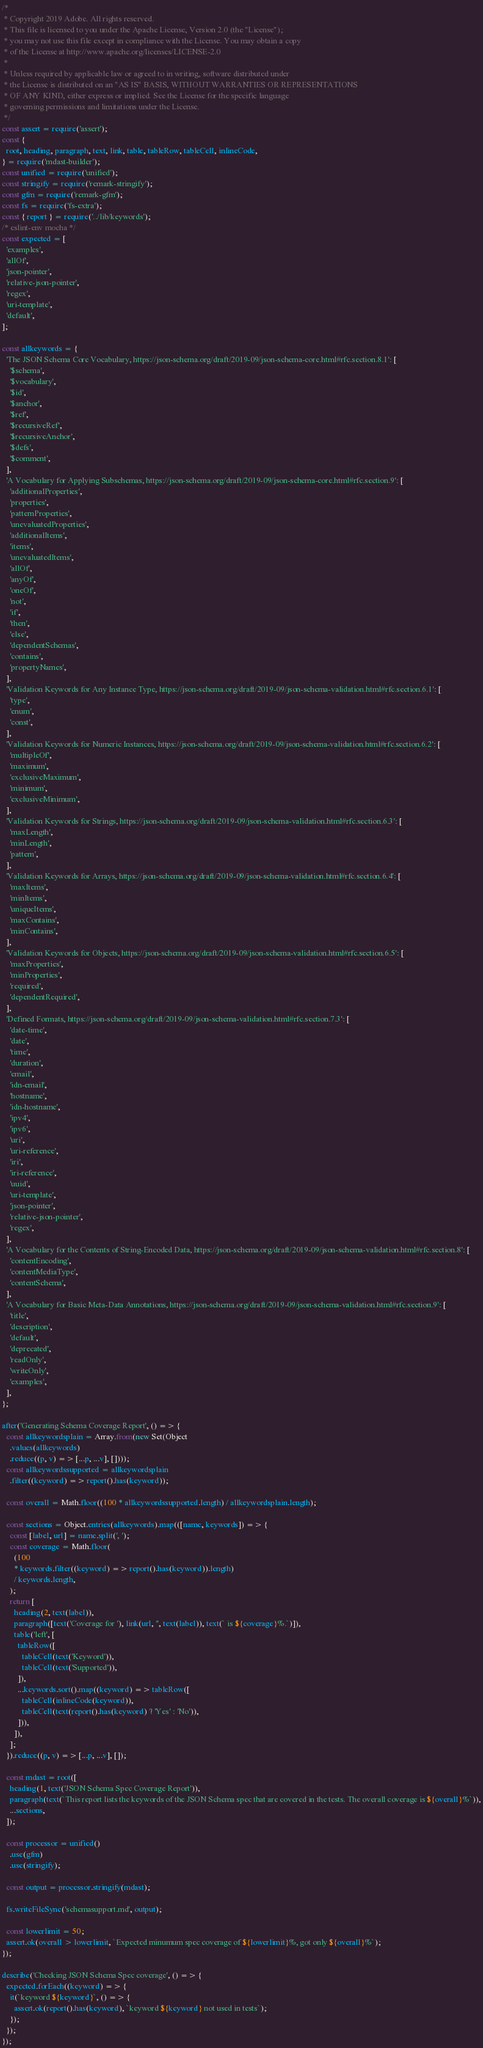<code> <loc_0><loc_0><loc_500><loc_500><_JavaScript_>/*
 * Copyright 2019 Adobe. All rights reserved.
 * This file is licensed to you under the Apache License, Version 2.0 (the "License");
 * you may not use this file except in compliance with the License. You may obtain a copy
 * of the License at http://www.apache.org/licenses/LICENSE-2.0
 *
 * Unless required by applicable law or agreed to in writing, software distributed under
 * the License is distributed on an "AS IS" BASIS, WITHOUT WARRANTIES OR REPRESENTATIONS
 * OF ANY KIND, either express or implied. See the License for the specific language
 * governing permissions and limitations under the License.
 */
const assert = require('assert');
const {
  root, heading, paragraph, text, link, table, tableRow, tableCell, inlineCode,
} = require('mdast-builder');
const unified = require('unified');
const stringify = require('remark-stringify');
const gfm = require('remark-gfm');
const fs = require('fs-extra');
const { report } = require('../lib/keywords');
/* eslint-env mocha */
const expected = [
  'examples',
  'allOf',
  'json-pointer',
  'relative-json-pointer',
  'regex',
  'uri-template',
  'default',
];

const allkeywords = {
  'The JSON Schema Core Vocabulary, https://json-schema.org/draft/2019-09/json-schema-core.html#rfc.section.8.1': [
    '$schema',
    '$vocabulary',
    '$id',
    '$anchor',
    '$ref',
    '$recursiveRef',
    '$recursiveAnchor',
    '$defs',
    '$comment',
  ],
  'A Vocabulary for Applying Subschemas, https://json-schema.org/draft/2019-09/json-schema-core.html#rfc.section.9': [
    'additionalProperties',
    'properties',
    'patternProperties',
    'unevaluatedProperties',
    'additionalItems',
    'items',
    'unevaluatedItems',
    'allOf',
    'anyOf',
    'oneOf',
    'not',
    'if',
    'then',
    'else',
    'dependentSchemas',
    'contains',
    'propertyNames',
  ],
  'Validation Keywords for Any Instance Type, https://json-schema.org/draft/2019-09/json-schema-validation.html#rfc.section.6.1': [
    'type',
    'enum',
    'const',
  ],
  'Validation Keywords for Numeric Instances, https://json-schema.org/draft/2019-09/json-schema-validation.html#rfc.section.6.2': [
    'multipleOf',
    'maximum',
    'exclusiveMaximum',
    'minimum',
    'exclusiveMinimum',
  ],
  'Validation Keywords for Strings, https://json-schema.org/draft/2019-09/json-schema-validation.html#rfc.section.6.3': [
    'maxLength',
    'minLength',
    'pattern',
  ],
  'Validation Keywords for Arrays, https://json-schema.org/draft/2019-09/json-schema-validation.html#rfc.section.6.4': [
    'maxItems',
    'minItems',
    'uniqueItems',
    'maxContains',
    'minContains',
  ],
  'Validation Keywords for Objects, https://json-schema.org/draft/2019-09/json-schema-validation.html#rfc.section.6.5': [
    'maxProperties',
    'minProperties',
    'required',
    'dependentRequired',
  ],
  'Defined Formats, https://json-schema.org/draft/2019-09/json-schema-validation.html#rfc.section.7.3': [
    'date-time',
    'date',
    'time',
    'duration',
    'email',
    'idn-email',
    'hostname',
    'idn-hostname',
    'ipv4',
    'ipv6',
    'uri',
    'uri-reference',
    'iri',
    'iri-reference',
    'uuid',
    'uri-template',
    'json-pointer',
    'relative-json-pointer',
    'regex',
  ],
  'A Vocabulary for the Contents of String-Encoded Data, https://json-schema.org/draft/2019-09/json-schema-validation.html#rfc.section.8': [
    'contentEncoding',
    'contentMediaType',
    'contentSchema',
  ],
  'A Vocabulary for Basic Meta-Data Annotations, https://json-schema.org/draft/2019-09/json-schema-validation.html#rfc.section.9': [
    'title',
    'description',
    'default',
    'deprecated',
    'readOnly',
    'writeOnly',
    'examples',
  ],
};

after('Generating Schema Coverage Report', () => {
  const allkeywordsplain = Array.from(new Set(Object
    .values(allkeywords)
    .reduce((p, v) => [...p, ...v], [])));
  const allkeywordssupported = allkeywordsplain
    .filter((keyword) => report().has(keyword));

  const overall = Math.floor((100 * allkeywordssupported.length) / allkeywordsplain.length);

  const sections = Object.entries(allkeywords).map(([name, keywords]) => {
    const [label, url] = name.split(', ');
    const coverage = Math.floor(
      (100
      * keywords.filter((keyword) => report().has(keyword)).length)
      / keywords.length,
    );
    return [
      heading(2, text(label)),
      paragraph([text('Coverage for '), link(url, '', text(label)), text(` is ${coverage}%.`)]),
      table('left', [
        tableRow([
          tableCell(text('Keyword')),
          tableCell(text('Supported')),
        ]),
        ...keywords.sort().map((keyword) => tableRow([
          tableCell(inlineCode(keyword)),
          tableCell(text(report().has(keyword) ? 'Yes' : 'No')),
        ])),
      ]),
    ];
  }).reduce((p, v) => [...p, ...v], []);

  const mdast = root([
    heading(1, text('JSON Schema Spec Coverage Report')),
    paragraph(text(`This report lists the keywords of the JSON Schema spec that are covered in the tests. The overall coverage is ${overall}%`)),
    ...sections,
  ]);

  const processor = unified()
    .use(gfm)
    .use(stringify);

  const output = processor.stringify(mdast);

  fs.writeFileSync('schemasupport.md', output);

  const lowerlimit = 50;
  assert.ok(overall > lowerlimit, `Expected minumum spec coverage of ${lowerlimit}%, got only ${overall}%`);
});

describe('Checking JSON Schema Spec coverage', () => {
  expected.forEach((keyword) => {
    it(`keyword ${keyword}`, () => {
      assert.ok(report().has(keyword), `keyword ${keyword} not used in tests`);
    });
  });
});
</code> 